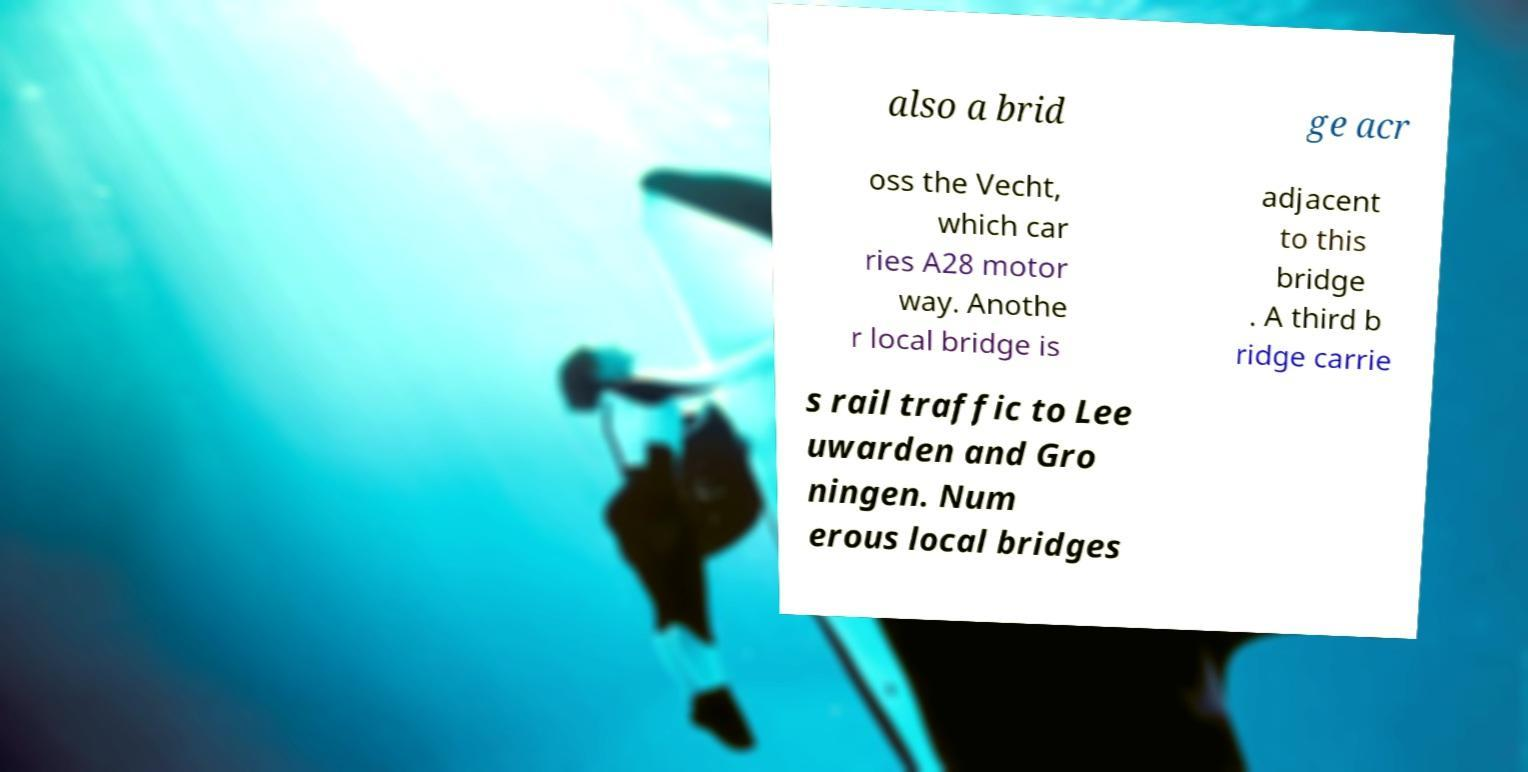Can you accurately transcribe the text from the provided image for me? also a brid ge acr oss the Vecht, which car ries A28 motor way. Anothe r local bridge is adjacent to this bridge . A third b ridge carrie s rail traffic to Lee uwarden and Gro ningen. Num erous local bridges 